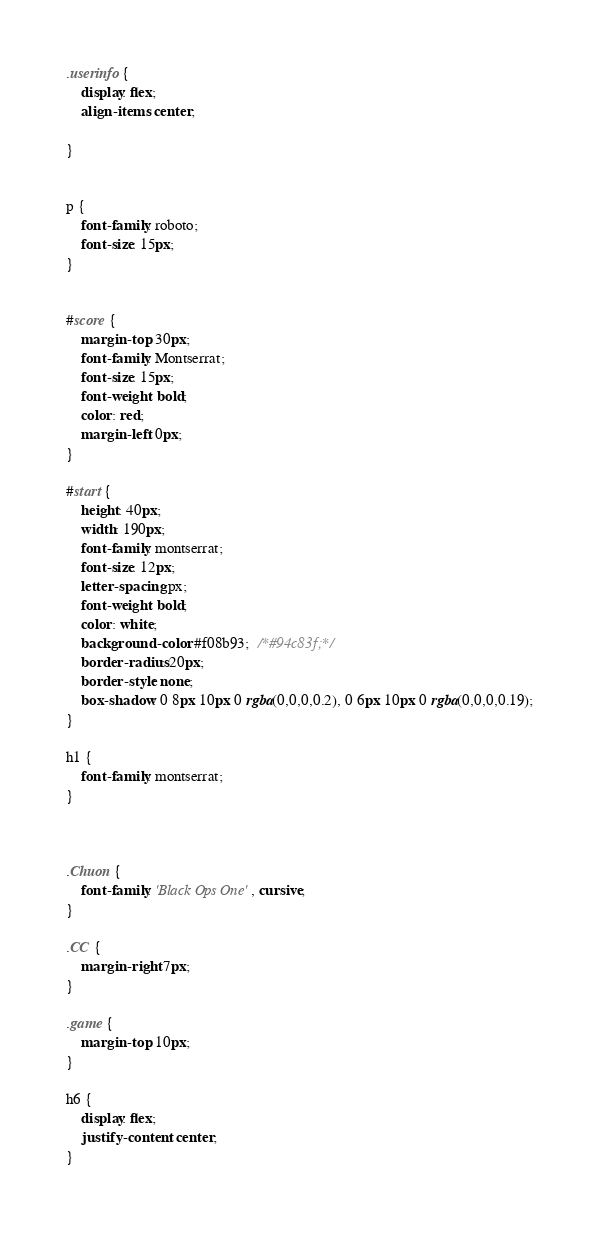<code> <loc_0><loc_0><loc_500><loc_500><_CSS_>
.userinfo {
    display: flex;
    align-items: center;
    
}

 
p {
    font-family: roboto;
    font-size: 15px;
}


#score {
    margin-top: 30px;
    font-family: Montserrat;
    font-size: 15px;
    font-weight: bold;
    color: red;
    margin-left: 0px;
}

#start {
    height: 40px;
    width: 190px;
    font-family: montserrat;
    font-size: 12px;
    letter-spacing: px;
    font-weight: bold;
    color: white;
    background-color: #f08b93;  /*#94c83f;*/
    border-radius: 20px;
    border-style: none;
    box-shadow: 0 8px 10px 0 rgba(0,0,0,0.2), 0 6px 10px 0 rgba(0,0,0,0.19);
}

h1 {
    font-family: montserrat;
}



.Chuon {
    font-family: 'Black Ops One', cursive;
}

.CC {
    margin-right: 7px;
}

.game {
    margin-top: 10px;
}

h6 {
    display: flex;
    justify-content: center;
}</code> 